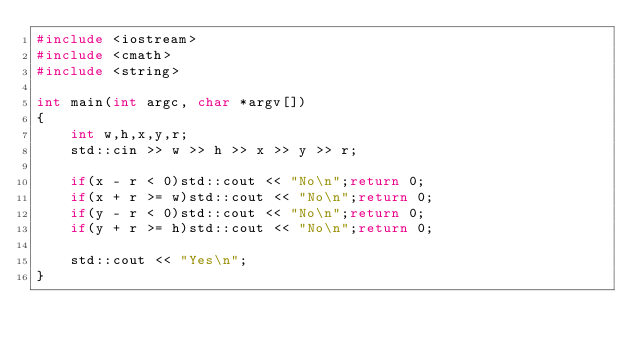<code> <loc_0><loc_0><loc_500><loc_500><_C++_>#include <iostream>
#include <cmath>
#include <string>

int main(int argc, char *argv[])
{
    int w,h,x,y,r;
    std::cin >> w >> h >> x >> y >> r;

    if(x - r < 0)std::cout << "No\n";return 0;
    if(x + r >= w)std::cout << "No\n";return 0;
    if(y - r < 0)std::cout << "No\n";return 0;
    if(y + r >= h)std::cout << "No\n";return 0;

    std::cout << "Yes\n";
}</code> 